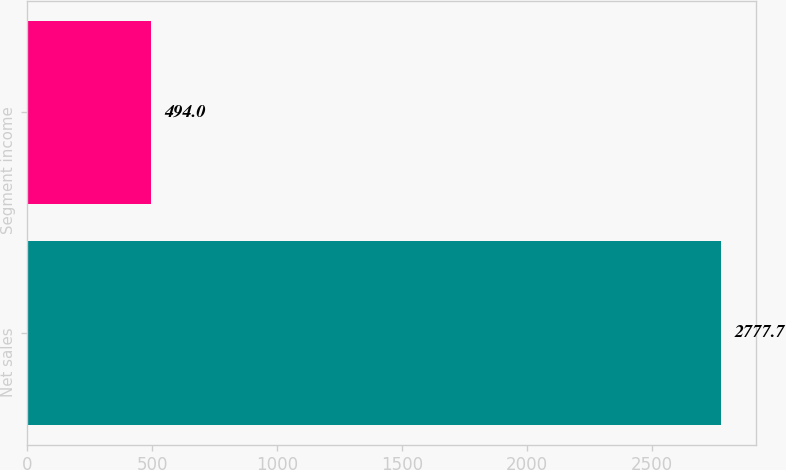Convert chart. <chart><loc_0><loc_0><loc_500><loc_500><bar_chart><fcel>Net sales<fcel>Segment income<nl><fcel>2777.7<fcel>494<nl></chart> 